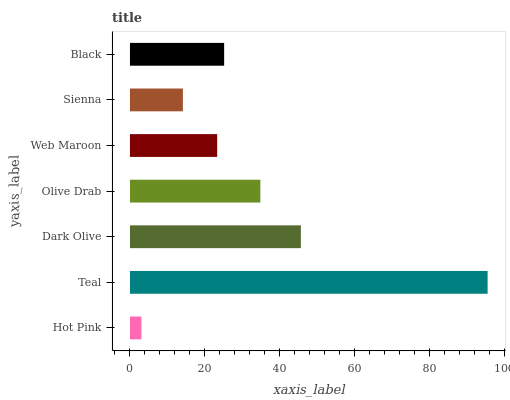Is Hot Pink the minimum?
Answer yes or no. Yes. Is Teal the maximum?
Answer yes or no. Yes. Is Dark Olive the minimum?
Answer yes or no. No. Is Dark Olive the maximum?
Answer yes or no. No. Is Teal greater than Dark Olive?
Answer yes or no. Yes. Is Dark Olive less than Teal?
Answer yes or no. Yes. Is Dark Olive greater than Teal?
Answer yes or no. No. Is Teal less than Dark Olive?
Answer yes or no. No. Is Black the high median?
Answer yes or no. Yes. Is Black the low median?
Answer yes or no. Yes. Is Web Maroon the high median?
Answer yes or no. No. Is Web Maroon the low median?
Answer yes or no. No. 